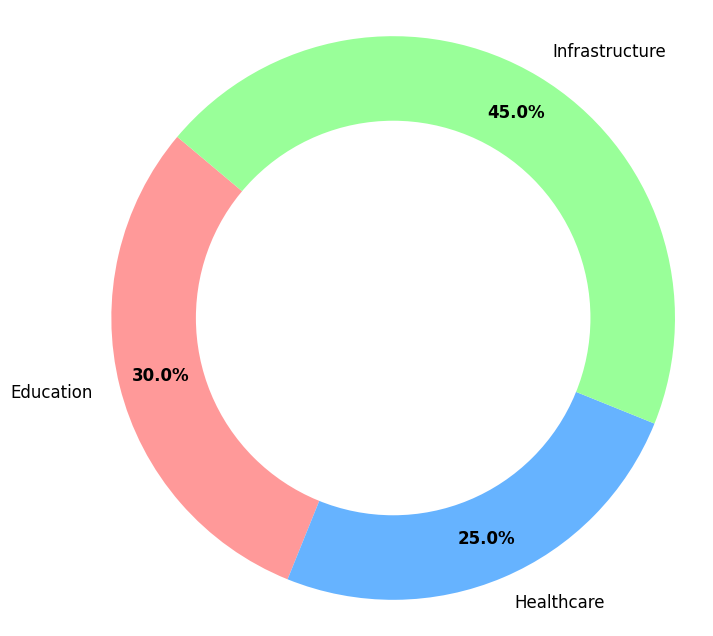what percentage of the total revenue is allocated to education? Education comprises 30% of the revenue. We can see this directly from the chart, where the section labeled "Education" shows "30.0%" on it.
Answer: 30% Is the allocation for infrastructure greater than the combined allocation for education and healthcare? The allocation for infrastructure is 45%, while the combined allocation for education (30%) and healthcare (25%) is 30% + 25% = 55%. Since 45% is less than 55%, the allocation for infrastructure is not greater.
Answer: No How much more percentage of revenue is allocated to infrastructure than to healthcare? The revenue allocation for infrastructure is 45%, and for healthcare, it's 25%. So, the difference is 45% - 25% = 20%. Hence, 20% more revenue is allocated to infrastructure than to healthcare.
Answer: 20% What fraction of the total allocation is dedicated to education and healthcare combined? Education gets 30% and healthcare gets 25% of the allocations. Their combined allocation is 30% + 25% = 55%. This represents 55% of the total allocation.
Answer: 55% Which category has the lowest allocation, and what is that percentage? By inspecting the chart, healthcare has the lowest allocation, which is 25%.
Answer: Healthcare, 25% What is the color representation of the highest allocated category in the chart? The highest allocated category is infrastructure with 45%, represented by the green section in the ring chart.
Answer: Green Arrange the categories in descending order of their allocation. From the chart, we can see that the allocations are: Infrastructure (45%), Education (30%), and Healthcare (25%). Arranging these in descending order gives: Infrastructure, Education, Healthcare.
Answer: Infrastructure, Education, Healthcare What is the difference in allocations between education and healthcare? Education is allocated 30% and healthcare is allocated 25%. The difference is 30% - 25% = 5%.
Answer: 5% Calculate the average allocation of the three categories. To find the average allocation, sum up the percentages of the three categories and divide by the number of categories. (30% + 25% + 45%) / 3 = 100% / 3 = 33.33%.
Answer: 33.33% 